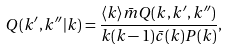Convert formula to latex. <formula><loc_0><loc_0><loc_500><loc_500>Q ( k ^ { \prime } , k ^ { \prime \prime } | k ) = \frac { \langle k \rangle \bar { m } Q ( k , k ^ { \prime } , k ^ { \prime \prime } ) } { k ( k - 1 ) \bar { c } ( k ) P ( k ) } ,</formula> 